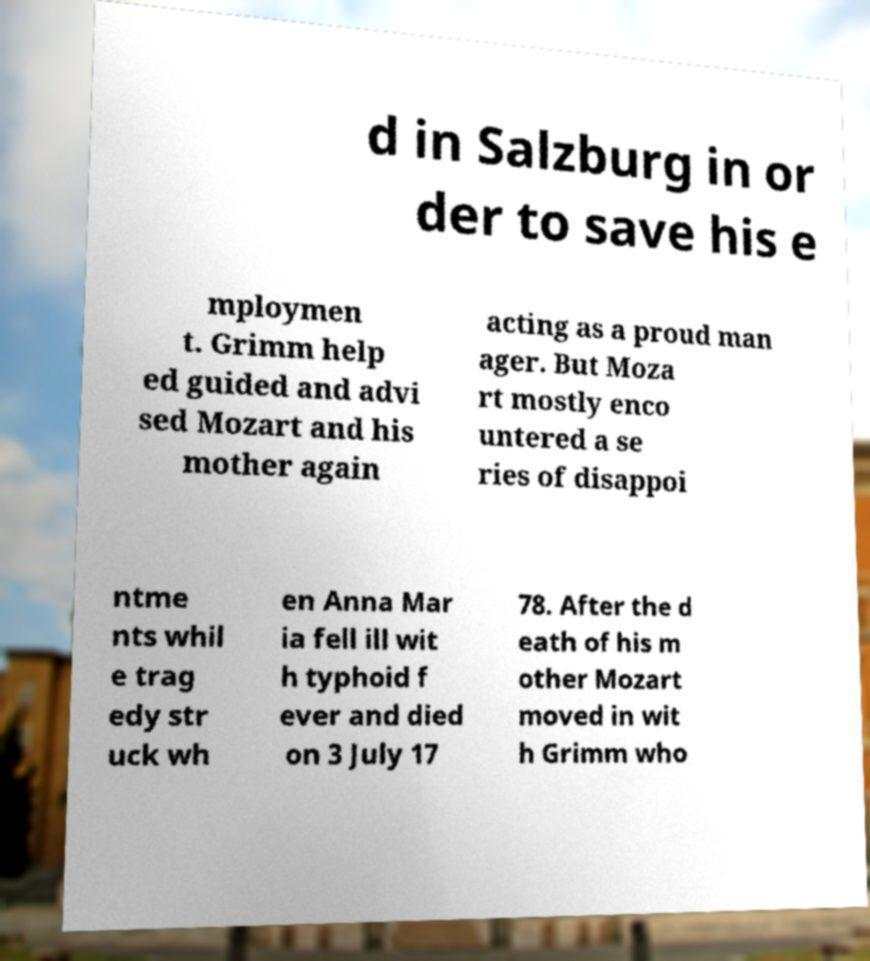For documentation purposes, I need the text within this image transcribed. Could you provide that? d in Salzburg in or der to save his e mploymen t. Grimm help ed guided and advi sed Mozart and his mother again acting as a proud man ager. But Moza rt mostly enco untered a se ries of disappoi ntme nts whil e trag edy str uck wh en Anna Mar ia fell ill wit h typhoid f ever and died on 3 July 17 78. After the d eath of his m other Mozart moved in wit h Grimm who 